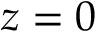<formula> <loc_0><loc_0><loc_500><loc_500>z = 0</formula> 